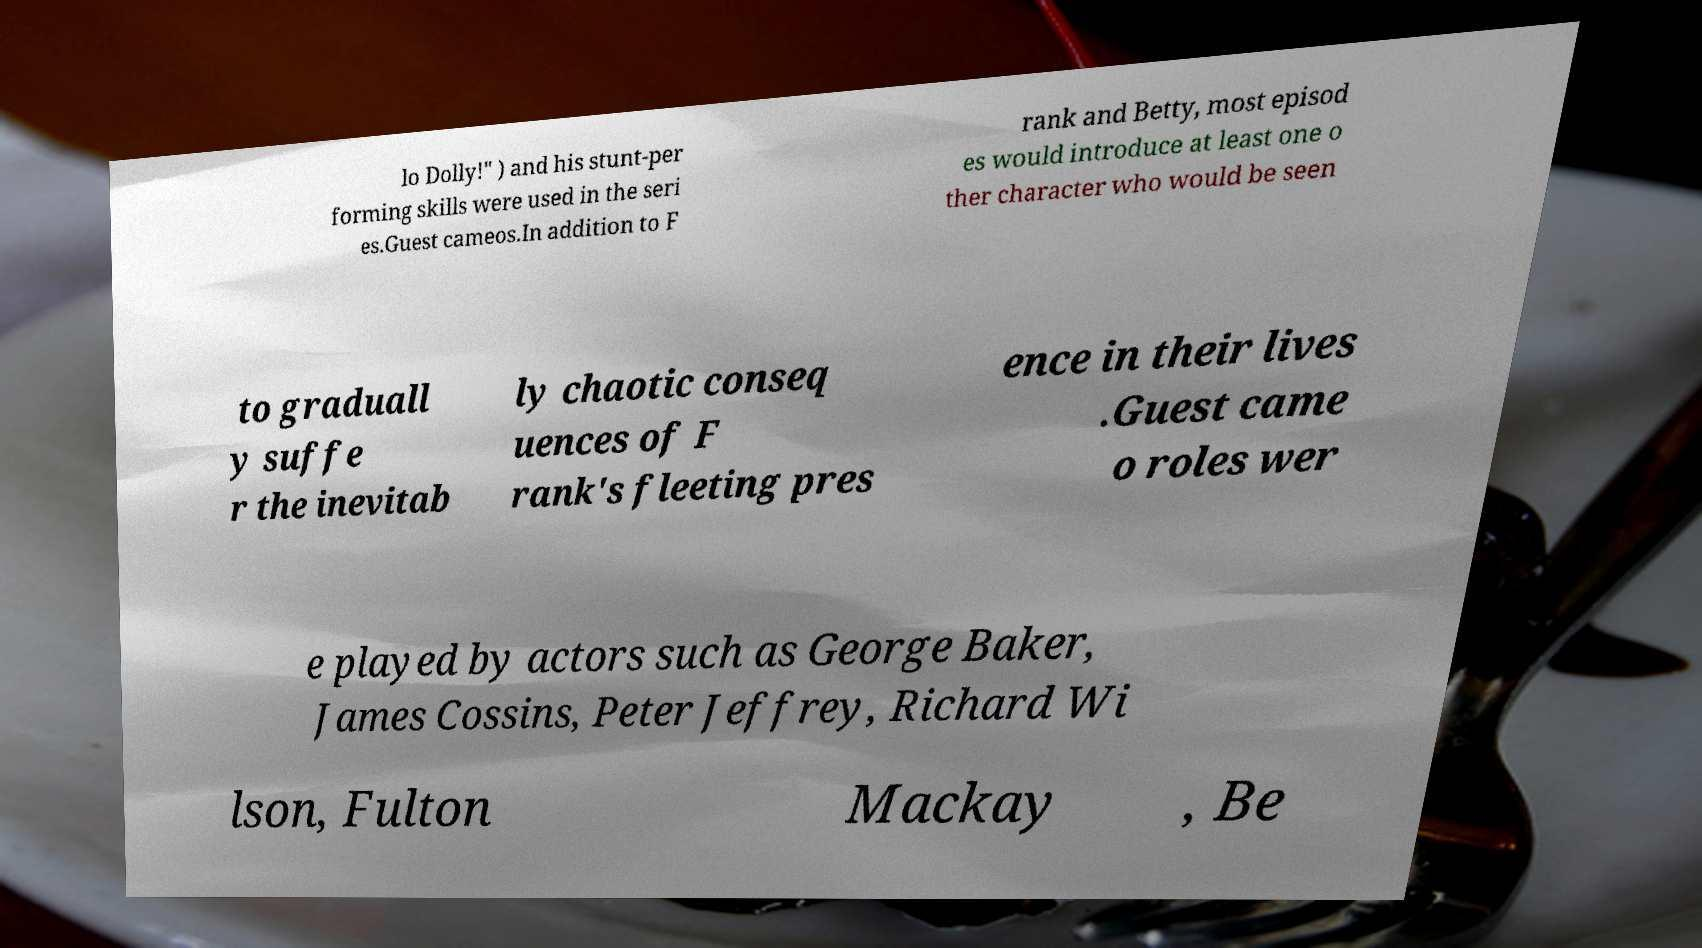Can you read and provide the text displayed in the image?This photo seems to have some interesting text. Can you extract and type it out for me? lo Dolly!" ) and his stunt-per forming skills were used in the seri es.Guest cameos.In addition to F rank and Betty, most episod es would introduce at least one o ther character who would be seen to graduall y suffe r the inevitab ly chaotic conseq uences of F rank's fleeting pres ence in their lives .Guest came o roles wer e played by actors such as George Baker, James Cossins, Peter Jeffrey, Richard Wi lson, Fulton Mackay , Be 